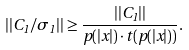Convert formula to latex. <formula><loc_0><loc_0><loc_500><loc_500>| | C _ { 1 } / \sigma _ { 1 } | | \geq \frac { | | C _ { 1 } | | } { p ( | x | ) \cdot t ( p ( | x | ) ) } .</formula> 